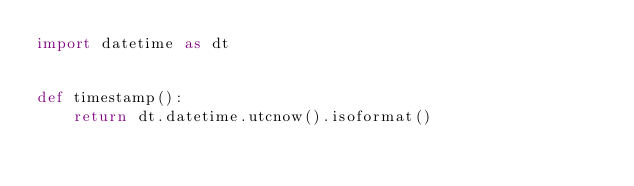<code> <loc_0><loc_0><loc_500><loc_500><_Python_>import datetime as dt


def timestamp():
    return dt.datetime.utcnow().isoformat()</code> 